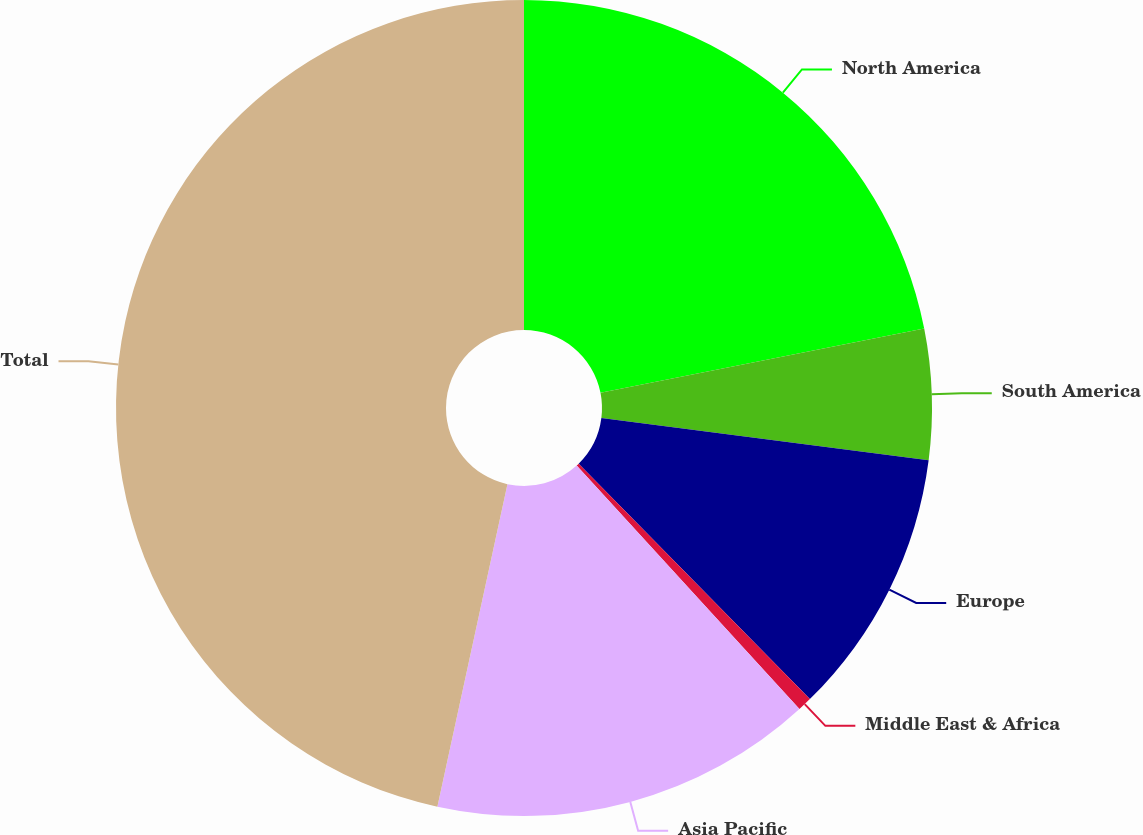Convert chart to OTSL. <chart><loc_0><loc_0><loc_500><loc_500><pie_chart><fcel>North America<fcel>South America<fcel>Europe<fcel>Middle East & Africa<fcel>Asia Pacific<fcel>Total<nl><fcel>21.88%<fcel>5.16%<fcel>10.6%<fcel>0.56%<fcel>15.2%<fcel>46.59%<nl></chart> 